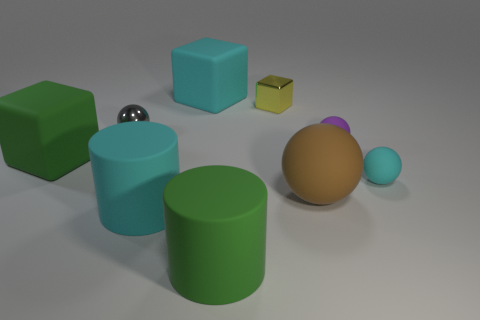Is the size of the green matte thing behind the large green cylinder the same as the metal thing right of the tiny metal ball?
Provide a short and direct response. No. How many other things are there of the same size as the green rubber cylinder?
Your answer should be compact. 4. What number of small shiny balls are in front of the cube in front of the tiny purple ball?
Ensure brevity in your answer.  0. Are there fewer yellow cubes that are behind the big green matte cylinder than balls?
Ensure brevity in your answer.  Yes. There is a large cyan matte thing in front of the rubber sphere behind the object that is on the left side of the tiny gray thing; what is its shape?
Offer a terse response. Cylinder. Is the shape of the tiny gray object the same as the tiny cyan object?
Give a very brief answer. Yes. What number of other things are there of the same shape as the brown thing?
Your answer should be compact. 3. There is a ball that is the same size as the cyan cylinder; what color is it?
Offer a terse response. Brown. Are there the same number of large cyan cubes that are in front of the cyan block and big brown rubber spheres?
Make the answer very short. No. There is a small object that is on the left side of the purple object and in front of the yellow metallic cube; what shape is it?
Make the answer very short. Sphere. 